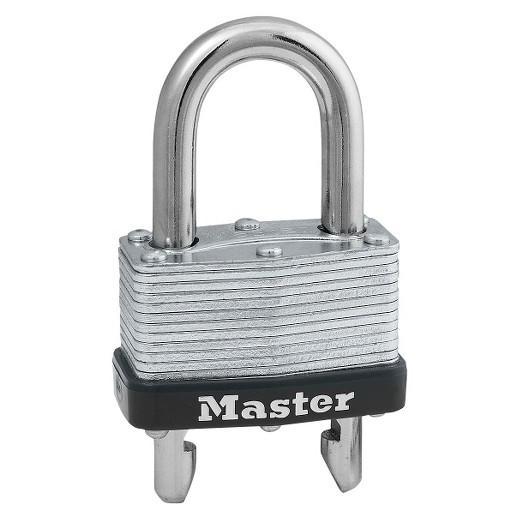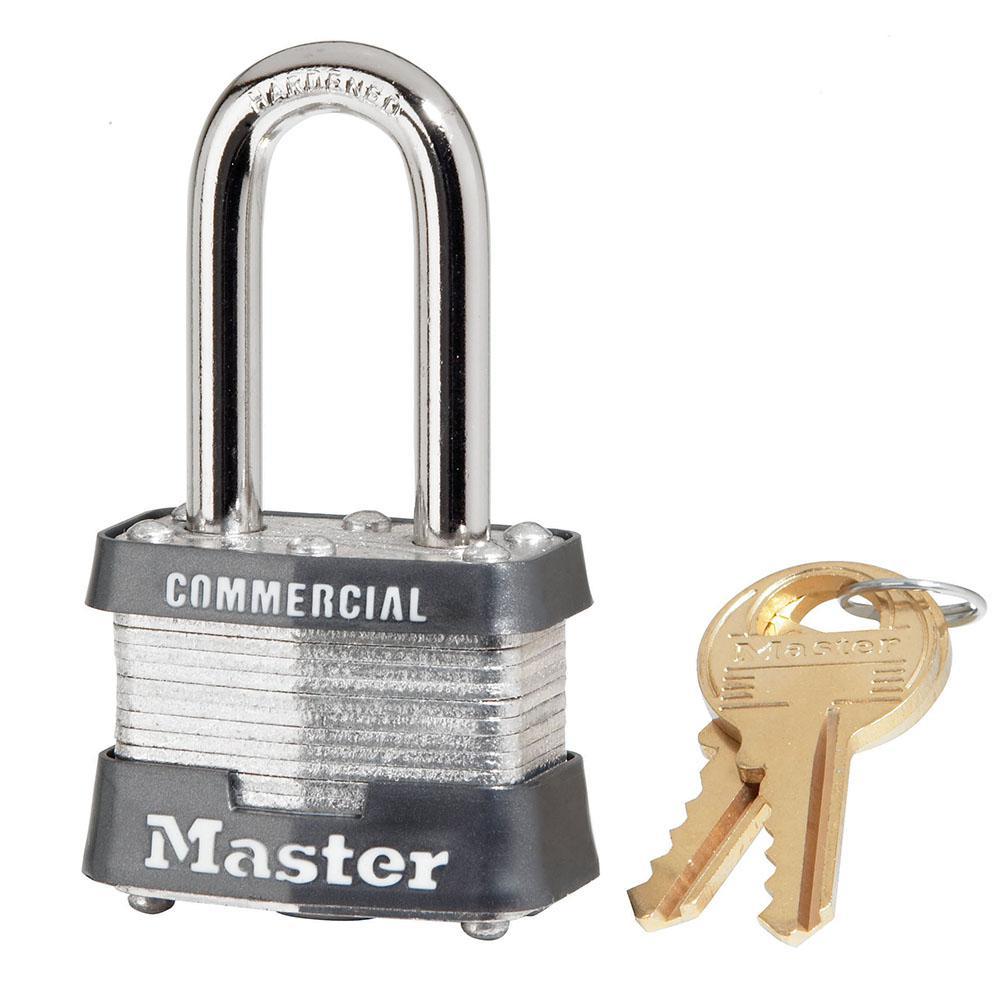The first image is the image on the left, the second image is the image on the right. Examine the images to the left and right. Is the description "Each image contains only one lock, and each lock has a silver loop at the top." accurate? Answer yes or no. Yes. 